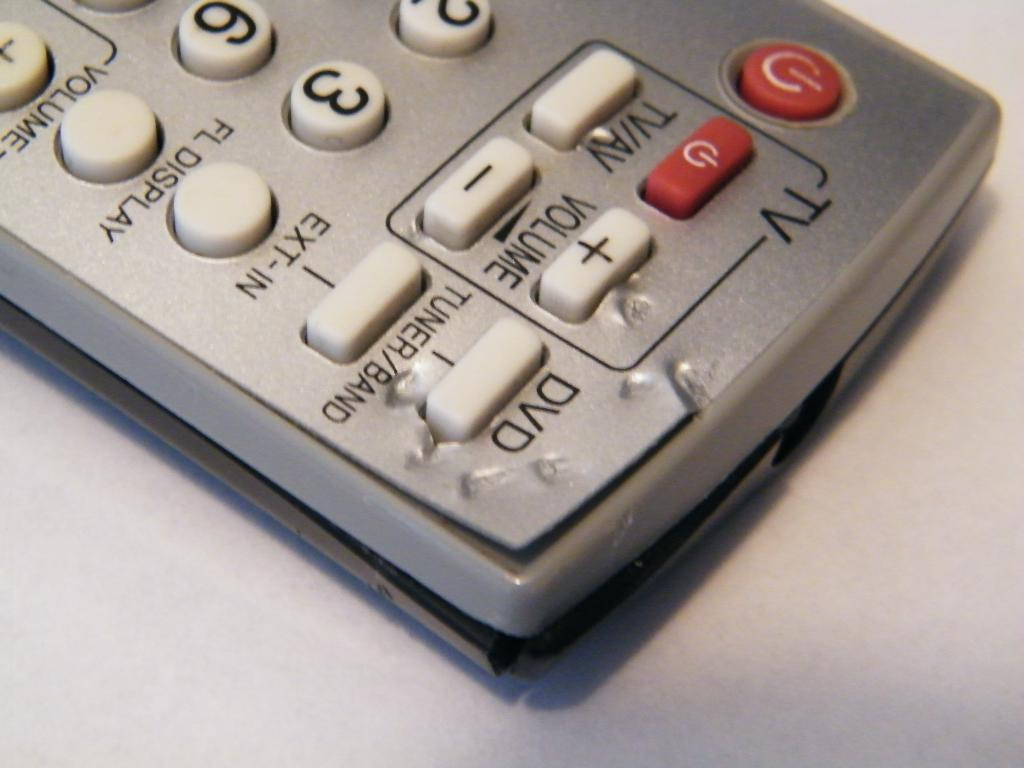<image>
Relay a brief, clear account of the picture shown. A silver remote with red and white buttons with DVD and TV written at the top. 